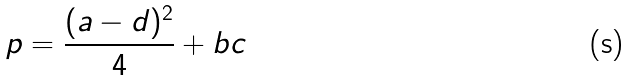Convert formula to latex. <formula><loc_0><loc_0><loc_500><loc_500>p = \frac { ( a - d ) ^ { 2 } } { 4 } + b c</formula> 